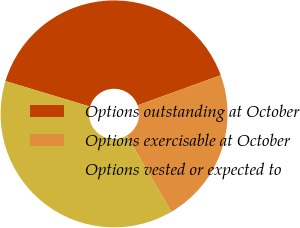<chart> <loc_0><loc_0><loc_500><loc_500><pie_chart><fcel>Options outstanding at October<fcel>Options exercisable at October<fcel>Options vested or expected to<nl><fcel>39.8%<fcel>22.12%<fcel>38.08%<nl></chart> 